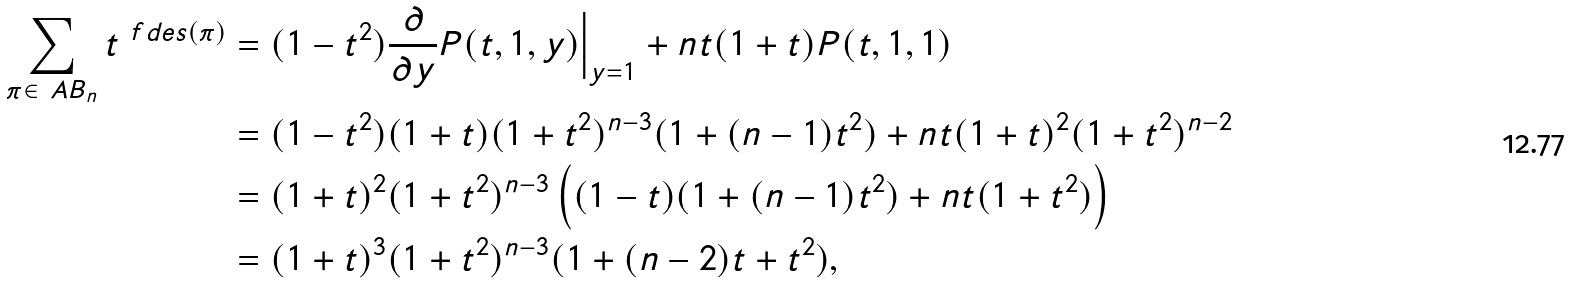Convert formula to latex. <formula><loc_0><loc_0><loc_500><loc_500>\sum _ { \pi \in \ A B _ { n } } t ^ { \ f d e s ( \pi ) } & = ( 1 - t ^ { 2 } ) \frac { \partial } { \partial y } P ( t , 1 , y ) \Big | _ { y = 1 } + n t ( 1 + t ) P ( t , 1 , 1 ) \\ & = ( 1 - t ^ { 2 } ) ( 1 + t ) ( 1 + t ^ { 2 } ) ^ { n - 3 } ( 1 + ( n - 1 ) t ^ { 2 } ) + n t ( 1 + t ) ^ { 2 } ( 1 + t ^ { 2 } ) ^ { n - 2 } \\ & = ( 1 + t ) ^ { 2 } ( 1 + t ^ { 2 } ) ^ { n - 3 } \left ( ( 1 - t ) ( 1 + ( n - 1 ) t ^ { 2 } ) + n t ( 1 + t ^ { 2 } ) \right ) \\ & = ( 1 + t ) ^ { 3 } ( 1 + t ^ { 2 } ) ^ { n - 3 } ( 1 + ( n - 2 ) t + t ^ { 2 } ) ,</formula> 